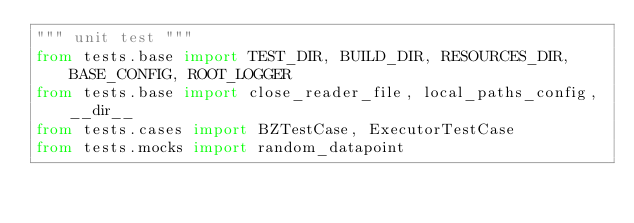<code> <loc_0><loc_0><loc_500><loc_500><_Python_>""" unit test """
from tests.base import TEST_DIR, BUILD_DIR, RESOURCES_DIR, BASE_CONFIG, ROOT_LOGGER
from tests.base import close_reader_file, local_paths_config, __dir__
from tests.cases import BZTestCase, ExecutorTestCase
from tests.mocks import random_datapoint
</code> 